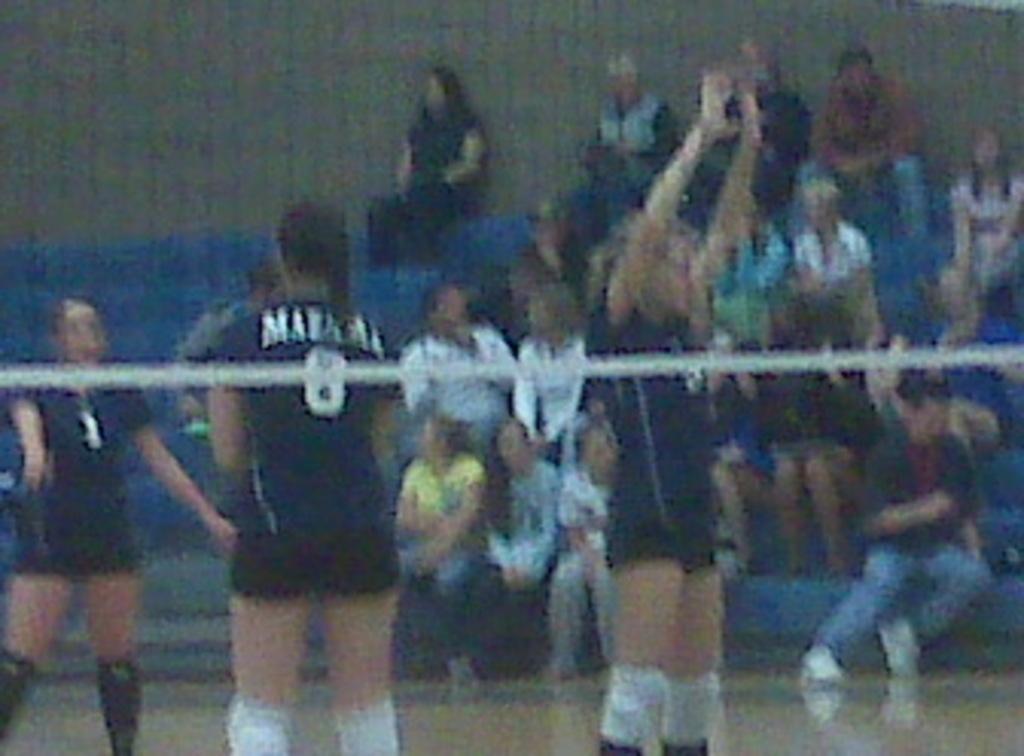Please provide a concise description of this image. In this image, we can see people wearing sports dress and there is a net. In the background, there are some other people. 